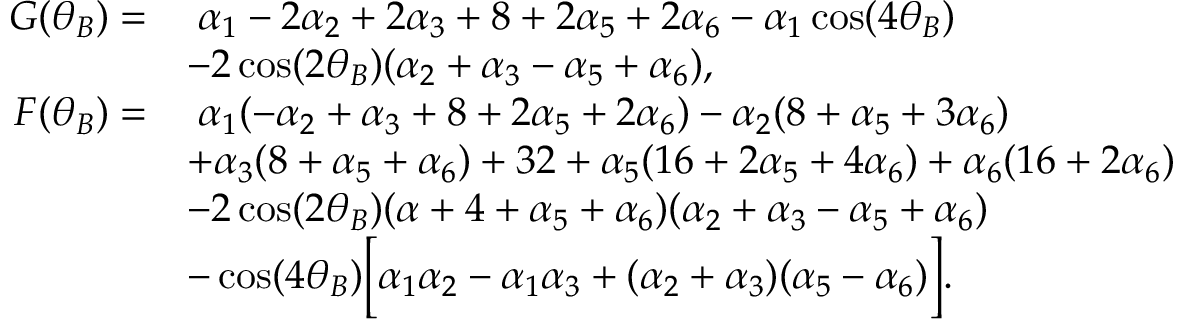<formula> <loc_0><loc_0><loc_500><loc_500>\begin{array} { r l } { G ( \theta _ { B } ) = } & { \, \alpha _ { 1 } - 2 \alpha _ { 2 } + 2 \alpha _ { 3 } + 8 + 2 \alpha _ { 5 } + 2 \alpha _ { 6 } - \alpha _ { 1 } \cos ( 4 \theta _ { B } ) } \\ & { - 2 \cos ( 2 \theta _ { B } ) ( \alpha _ { 2 } + \alpha _ { 3 } - \alpha _ { 5 } + \alpha _ { 6 } ) , } \\ { F ( \theta _ { B } ) = } & { \, \alpha _ { 1 } ( - \alpha _ { 2 } + \alpha _ { 3 } + 8 + 2 \alpha _ { 5 } + 2 \alpha _ { 6 } ) - \alpha _ { 2 } ( 8 + \alpha _ { 5 } + 3 \alpha _ { 6 } ) } \\ & { + \alpha _ { 3 } ( 8 + \alpha _ { 5 } + \alpha _ { 6 } ) + 3 2 + \alpha _ { 5 } ( 1 6 + 2 \alpha _ { 5 } + 4 \alpha _ { 6 } ) + \alpha _ { 6 } ( 1 6 + 2 \alpha _ { 6 } ) } \\ & { - 2 \cos ( 2 \theta _ { B } ) ( \alpha + 4 + \alpha _ { 5 } + \alpha _ { 6 } ) ( \alpha _ { 2 } + \alpha _ { 3 } - \alpha _ { 5 } + \alpha _ { 6 } ) } \\ & { - \cos ( 4 \theta _ { B } ) \left [ \alpha _ { 1 } \alpha _ { 2 } - \alpha _ { 1 } \alpha _ { 3 } + ( \alpha _ { 2 } + \alpha _ { 3 } ) ( \alpha _ { 5 } - \alpha _ { 6 } ) \right ] . } \end{array}</formula> 